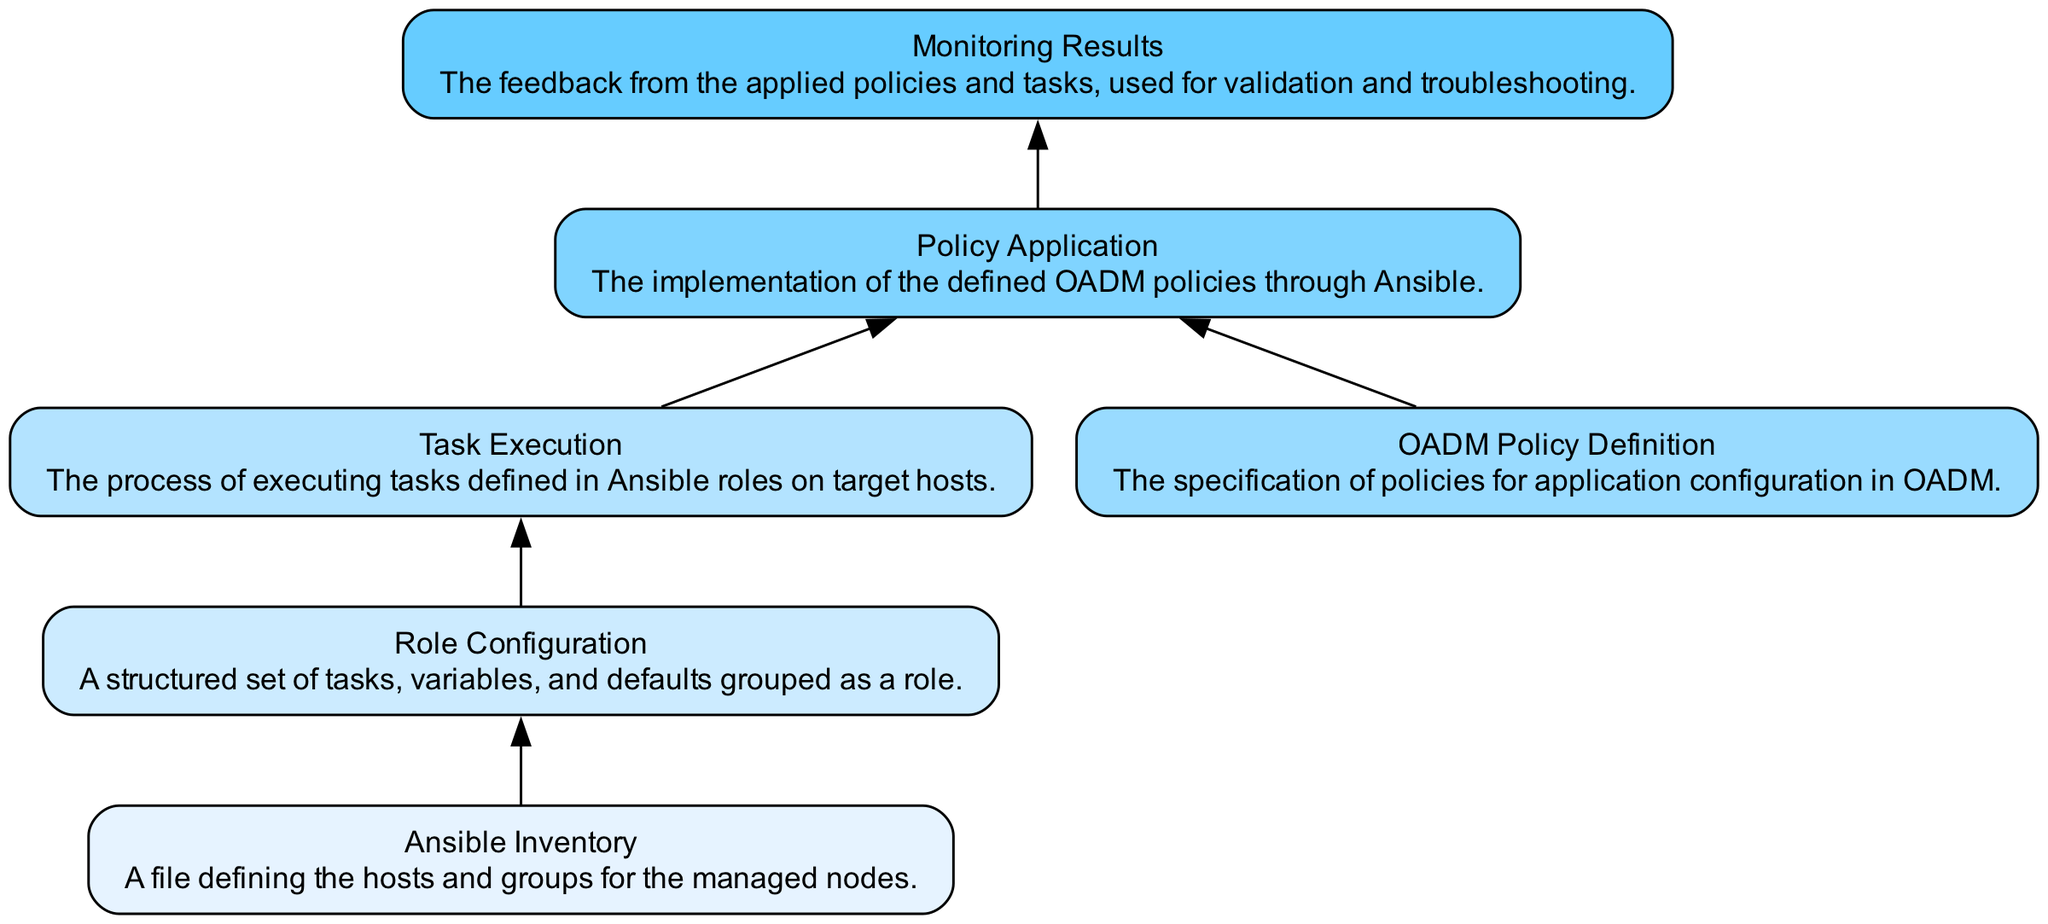What is the total number of nodes in the diagram? The diagram lists six distinct elements: Ansible Inventory, Role Configuration, Task Execution, OADM Policy Definition, Policy Application, and Monitoring Results. By counting these, the total number of nodes is six.
Answer: six What does the "Policy Application" node implement? According to the description, the "Policy Application" node implements the defined OADM policies through Ansible. This indicates that it is responsible for the application of the policies described earlier.
Answer: OADM policies Which node comes before "Task Execution"? The edge from "Role Configuration" to "Task Execution" indicates that "Role Configuration" is the node that comes before "Task Execution" in the flow. Thus, it is the prerequisite to executing tasks.
Answer: Role Configuration How many edges are present in the diagram? By reviewing the connections between the nodes, there are five edges that represent the flow: from Ansible Inventory to Role Configuration, from Role Configuration to Task Execution, from OADM Policy Definition to Policy Application, from Task Execution to Policy Application, and from Policy Application to Monitoring Results.
Answer: five What is the primary role of the "Monitoring Results" node? Based on its description, the primary role of the "Monitoring Results" node is to provide feedback from the applied policies and tasks, which can be used for further validation and troubleshooting.
Answer: feedback Which two nodes are directly connected to "Policy Application"? The nodes that are directly connected to "Policy Application" are "OADM Policy Definition" and "Task Execution", which flow into it. Thus, these nodes are essential inputs for the policy application's processes.
Answer: OADM Policy Definition and Task Execution What is the sequence of execution starting from "Ansible Inventory"? The flow begins at "Ansible Inventory", leading to "Role Configuration", then "Task Execution", followed by "Policy Application", and finally culminating in "Monitoring Results". This chain indicates the order in which components interact.
Answer: Ansible Inventory, Role Configuration, Task Execution, Policy Application, Monitoring Results Which node is responsible for defining OADM policies? The "OADM Policy Definition" node is explicitly responsible for the specification of policies for application configuration in OADM, indicating its pivotal role in policy setting before application.
Answer: OADM Policy Definition 